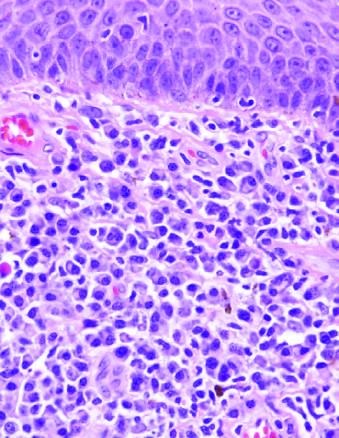do tubules include a diffuse plasma cell infiltrate beneath squamous epithelium of skin?
Answer the question using a single word or phrase. No 